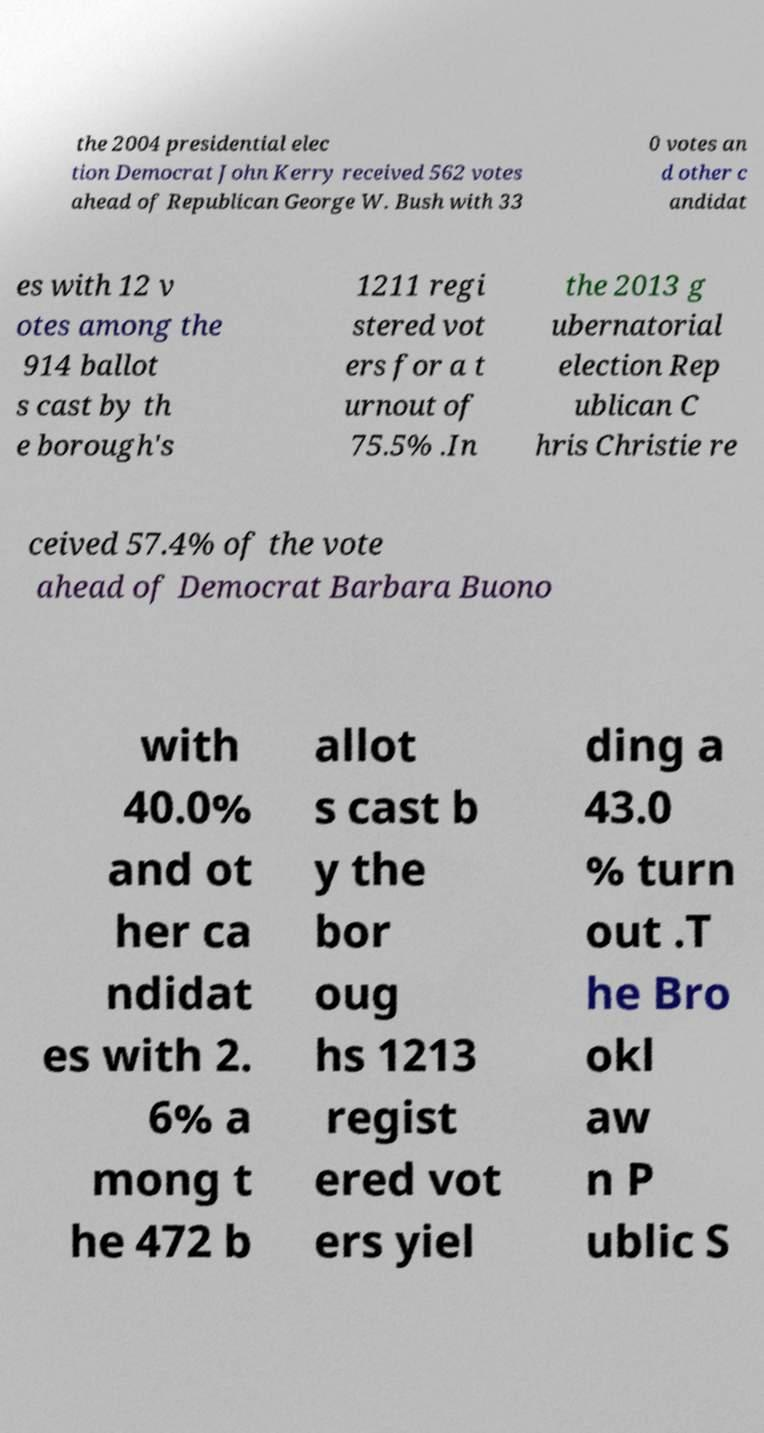Could you assist in decoding the text presented in this image and type it out clearly? the 2004 presidential elec tion Democrat John Kerry received 562 votes ahead of Republican George W. Bush with 33 0 votes an d other c andidat es with 12 v otes among the 914 ballot s cast by th e borough's 1211 regi stered vot ers for a t urnout of 75.5% .In the 2013 g ubernatorial election Rep ublican C hris Christie re ceived 57.4% of the vote ahead of Democrat Barbara Buono with 40.0% and ot her ca ndidat es with 2. 6% a mong t he 472 b allot s cast b y the bor oug hs 1213 regist ered vot ers yiel ding a 43.0 % turn out .T he Bro okl aw n P ublic S 